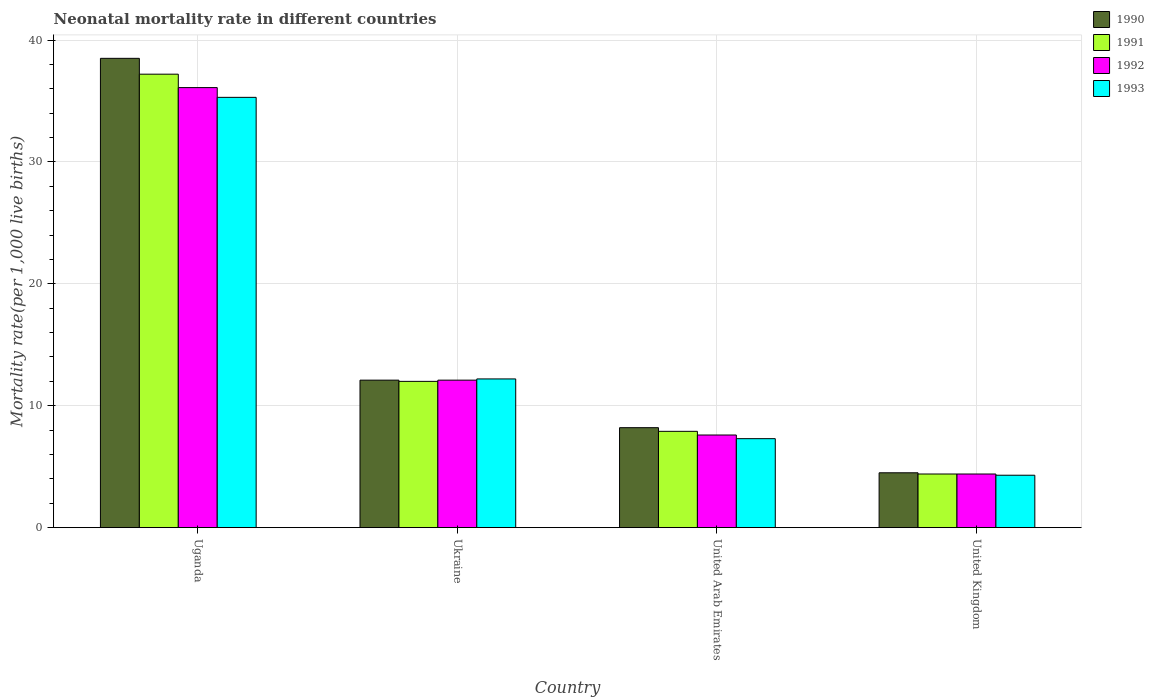How many different coloured bars are there?
Ensure brevity in your answer.  4. How many groups of bars are there?
Give a very brief answer. 4. What is the label of the 4th group of bars from the left?
Provide a succinct answer. United Kingdom. What is the neonatal mortality rate in 1990 in United Arab Emirates?
Offer a very short reply. 8.2. Across all countries, what is the maximum neonatal mortality rate in 1992?
Offer a terse response. 36.1. Across all countries, what is the minimum neonatal mortality rate in 1992?
Offer a terse response. 4.4. In which country was the neonatal mortality rate in 1990 maximum?
Offer a very short reply. Uganda. What is the total neonatal mortality rate in 1991 in the graph?
Offer a terse response. 61.5. What is the difference between the neonatal mortality rate in 1993 in United Kingdom and the neonatal mortality rate in 1991 in Uganda?
Ensure brevity in your answer.  -32.9. What is the average neonatal mortality rate in 1993 per country?
Make the answer very short. 14.77. What is the difference between the neonatal mortality rate of/in 1990 and neonatal mortality rate of/in 1992 in Uganda?
Your answer should be compact. 2.4. What is the ratio of the neonatal mortality rate in 1992 in Ukraine to that in United Arab Emirates?
Give a very brief answer. 1.59. Is the neonatal mortality rate in 1993 in Uganda less than that in United Arab Emirates?
Make the answer very short. No. Is the difference between the neonatal mortality rate in 1990 in Ukraine and United Arab Emirates greater than the difference between the neonatal mortality rate in 1992 in Ukraine and United Arab Emirates?
Provide a succinct answer. No. What is the difference between the highest and the second highest neonatal mortality rate in 1990?
Provide a short and direct response. -3.9. Is the sum of the neonatal mortality rate in 1992 in Uganda and United Arab Emirates greater than the maximum neonatal mortality rate in 1993 across all countries?
Provide a short and direct response. Yes. Is it the case that in every country, the sum of the neonatal mortality rate in 1990 and neonatal mortality rate in 1993 is greater than the sum of neonatal mortality rate in 1992 and neonatal mortality rate in 1991?
Ensure brevity in your answer.  No. How many bars are there?
Offer a very short reply. 16. Are all the bars in the graph horizontal?
Provide a succinct answer. No. How are the legend labels stacked?
Ensure brevity in your answer.  Vertical. What is the title of the graph?
Provide a succinct answer. Neonatal mortality rate in different countries. What is the label or title of the X-axis?
Your answer should be compact. Country. What is the label or title of the Y-axis?
Keep it short and to the point. Mortality rate(per 1,0 live births). What is the Mortality rate(per 1,000 live births) in 1990 in Uganda?
Your answer should be compact. 38.5. What is the Mortality rate(per 1,000 live births) in 1991 in Uganda?
Give a very brief answer. 37.2. What is the Mortality rate(per 1,000 live births) of 1992 in Uganda?
Keep it short and to the point. 36.1. What is the Mortality rate(per 1,000 live births) of 1993 in Uganda?
Your response must be concise. 35.3. What is the Mortality rate(per 1,000 live births) in 1990 in United Arab Emirates?
Keep it short and to the point. 8.2. What is the Mortality rate(per 1,000 live births) of 1993 in United Arab Emirates?
Give a very brief answer. 7.3. What is the Mortality rate(per 1,000 live births) of 1990 in United Kingdom?
Ensure brevity in your answer.  4.5. What is the Mortality rate(per 1,000 live births) in 1991 in United Kingdom?
Make the answer very short. 4.4. What is the Mortality rate(per 1,000 live births) of 1993 in United Kingdom?
Provide a short and direct response. 4.3. Across all countries, what is the maximum Mortality rate(per 1,000 live births) of 1990?
Offer a very short reply. 38.5. Across all countries, what is the maximum Mortality rate(per 1,000 live births) in 1991?
Your answer should be compact. 37.2. Across all countries, what is the maximum Mortality rate(per 1,000 live births) of 1992?
Your answer should be compact. 36.1. Across all countries, what is the maximum Mortality rate(per 1,000 live births) of 1993?
Keep it short and to the point. 35.3. Across all countries, what is the minimum Mortality rate(per 1,000 live births) in 1990?
Your answer should be very brief. 4.5. Across all countries, what is the minimum Mortality rate(per 1,000 live births) in 1992?
Keep it short and to the point. 4.4. Across all countries, what is the minimum Mortality rate(per 1,000 live births) in 1993?
Provide a short and direct response. 4.3. What is the total Mortality rate(per 1,000 live births) in 1990 in the graph?
Your answer should be very brief. 63.3. What is the total Mortality rate(per 1,000 live births) in 1991 in the graph?
Ensure brevity in your answer.  61.5. What is the total Mortality rate(per 1,000 live births) in 1992 in the graph?
Provide a succinct answer. 60.2. What is the total Mortality rate(per 1,000 live births) in 1993 in the graph?
Make the answer very short. 59.1. What is the difference between the Mortality rate(per 1,000 live births) in 1990 in Uganda and that in Ukraine?
Offer a very short reply. 26.4. What is the difference between the Mortality rate(per 1,000 live births) of 1991 in Uganda and that in Ukraine?
Your answer should be compact. 25.2. What is the difference between the Mortality rate(per 1,000 live births) in 1993 in Uganda and that in Ukraine?
Offer a very short reply. 23.1. What is the difference between the Mortality rate(per 1,000 live births) in 1990 in Uganda and that in United Arab Emirates?
Keep it short and to the point. 30.3. What is the difference between the Mortality rate(per 1,000 live births) in 1991 in Uganda and that in United Arab Emirates?
Offer a very short reply. 29.3. What is the difference between the Mortality rate(per 1,000 live births) of 1992 in Uganda and that in United Arab Emirates?
Your answer should be compact. 28.5. What is the difference between the Mortality rate(per 1,000 live births) in 1993 in Uganda and that in United Arab Emirates?
Offer a terse response. 28. What is the difference between the Mortality rate(per 1,000 live births) in 1990 in Uganda and that in United Kingdom?
Offer a very short reply. 34. What is the difference between the Mortality rate(per 1,000 live births) in 1991 in Uganda and that in United Kingdom?
Your response must be concise. 32.8. What is the difference between the Mortality rate(per 1,000 live births) in 1992 in Uganda and that in United Kingdom?
Your answer should be compact. 31.7. What is the difference between the Mortality rate(per 1,000 live births) in 1993 in Uganda and that in United Kingdom?
Keep it short and to the point. 31. What is the difference between the Mortality rate(per 1,000 live births) of 1991 in Ukraine and that in United Arab Emirates?
Offer a terse response. 4.1. What is the difference between the Mortality rate(per 1,000 live births) of 1992 in Ukraine and that in United Arab Emirates?
Give a very brief answer. 4.5. What is the difference between the Mortality rate(per 1,000 live births) of 1990 in Ukraine and that in United Kingdom?
Offer a very short reply. 7.6. What is the difference between the Mortality rate(per 1,000 live births) of 1991 in Ukraine and that in United Kingdom?
Provide a short and direct response. 7.6. What is the difference between the Mortality rate(per 1,000 live births) of 1993 in Ukraine and that in United Kingdom?
Provide a short and direct response. 7.9. What is the difference between the Mortality rate(per 1,000 live births) in 1992 in United Arab Emirates and that in United Kingdom?
Give a very brief answer. 3.2. What is the difference between the Mortality rate(per 1,000 live births) of 1990 in Uganda and the Mortality rate(per 1,000 live births) of 1992 in Ukraine?
Your response must be concise. 26.4. What is the difference between the Mortality rate(per 1,000 live births) in 1990 in Uganda and the Mortality rate(per 1,000 live births) in 1993 in Ukraine?
Ensure brevity in your answer.  26.3. What is the difference between the Mortality rate(per 1,000 live births) of 1991 in Uganda and the Mortality rate(per 1,000 live births) of 1992 in Ukraine?
Your answer should be very brief. 25.1. What is the difference between the Mortality rate(per 1,000 live births) of 1991 in Uganda and the Mortality rate(per 1,000 live births) of 1993 in Ukraine?
Ensure brevity in your answer.  25. What is the difference between the Mortality rate(per 1,000 live births) in 1992 in Uganda and the Mortality rate(per 1,000 live births) in 1993 in Ukraine?
Your response must be concise. 23.9. What is the difference between the Mortality rate(per 1,000 live births) of 1990 in Uganda and the Mortality rate(per 1,000 live births) of 1991 in United Arab Emirates?
Keep it short and to the point. 30.6. What is the difference between the Mortality rate(per 1,000 live births) of 1990 in Uganda and the Mortality rate(per 1,000 live births) of 1992 in United Arab Emirates?
Your answer should be very brief. 30.9. What is the difference between the Mortality rate(per 1,000 live births) in 1990 in Uganda and the Mortality rate(per 1,000 live births) in 1993 in United Arab Emirates?
Your response must be concise. 31.2. What is the difference between the Mortality rate(per 1,000 live births) in 1991 in Uganda and the Mortality rate(per 1,000 live births) in 1992 in United Arab Emirates?
Your response must be concise. 29.6. What is the difference between the Mortality rate(per 1,000 live births) in 1991 in Uganda and the Mortality rate(per 1,000 live births) in 1993 in United Arab Emirates?
Your answer should be very brief. 29.9. What is the difference between the Mortality rate(per 1,000 live births) of 1992 in Uganda and the Mortality rate(per 1,000 live births) of 1993 in United Arab Emirates?
Your answer should be compact. 28.8. What is the difference between the Mortality rate(per 1,000 live births) in 1990 in Uganda and the Mortality rate(per 1,000 live births) in 1991 in United Kingdom?
Offer a very short reply. 34.1. What is the difference between the Mortality rate(per 1,000 live births) in 1990 in Uganda and the Mortality rate(per 1,000 live births) in 1992 in United Kingdom?
Make the answer very short. 34.1. What is the difference between the Mortality rate(per 1,000 live births) of 1990 in Uganda and the Mortality rate(per 1,000 live births) of 1993 in United Kingdom?
Your response must be concise. 34.2. What is the difference between the Mortality rate(per 1,000 live births) in 1991 in Uganda and the Mortality rate(per 1,000 live births) in 1992 in United Kingdom?
Give a very brief answer. 32.8. What is the difference between the Mortality rate(per 1,000 live births) of 1991 in Uganda and the Mortality rate(per 1,000 live births) of 1993 in United Kingdom?
Your answer should be compact. 32.9. What is the difference between the Mortality rate(per 1,000 live births) in 1992 in Uganda and the Mortality rate(per 1,000 live births) in 1993 in United Kingdom?
Provide a succinct answer. 31.8. What is the difference between the Mortality rate(per 1,000 live births) in 1990 in Ukraine and the Mortality rate(per 1,000 live births) in 1992 in United Arab Emirates?
Your answer should be very brief. 4.5. What is the difference between the Mortality rate(per 1,000 live births) of 1990 in Ukraine and the Mortality rate(per 1,000 live births) of 1993 in United Arab Emirates?
Give a very brief answer. 4.8. What is the difference between the Mortality rate(per 1,000 live births) in 1991 in Ukraine and the Mortality rate(per 1,000 live births) in 1992 in United Arab Emirates?
Offer a terse response. 4.4. What is the difference between the Mortality rate(per 1,000 live births) in 1992 in Ukraine and the Mortality rate(per 1,000 live births) in 1993 in United Arab Emirates?
Your answer should be very brief. 4.8. What is the difference between the Mortality rate(per 1,000 live births) in 1990 in Ukraine and the Mortality rate(per 1,000 live births) in 1991 in United Kingdom?
Offer a very short reply. 7.7. What is the difference between the Mortality rate(per 1,000 live births) in 1990 in Ukraine and the Mortality rate(per 1,000 live births) in 1993 in United Kingdom?
Your answer should be compact. 7.8. What is the difference between the Mortality rate(per 1,000 live births) of 1991 in Ukraine and the Mortality rate(per 1,000 live births) of 1992 in United Kingdom?
Offer a very short reply. 7.6. What is the difference between the Mortality rate(per 1,000 live births) in 1992 in Ukraine and the Mortality rate(per 1,000 live births) in 1993 in United Kingdom?
Your answer should be very brief. 7.8. What is the average Mortality rate(per 1,000 live births) in 1990 per country?
Give a very brief answer. 15.82. What is the average Mortality rate(per 1,000 live births) of 1991 per country?
Give a very brief answer. 15.38. What is the average Mortality rate(per 1,000 live births) in 1992 per country?
Your response must be concise. 15.05. What is the average Mortality rate(per 1,000 live births) in 1993 per country?
Ensure brevity in your answer.  14.78. What is the difference between the Mortality rate(per 1,000 live births) of 1990 and Mortality rate(per 1,000 live births) of 1993 in Uganda?
Provide a succinct answer. 3.2. What is the difference between the Mortality rate(per 1,000 live births) in 1991 and Mortality rate(per 1,000 live births) in 1993 in Uganda?
Give a very brief answer. 1.9. What is the difference between the Mortality rate(per 1,000 live births) of 1992 and Mortality rate(per 1,000 live births) of 1993 in Uganda?
Offer a terse response. 0.8. What is the difference between the Mortality rate(per 1,000 live births) in 1990 and Mortality rate(per 1,000 live births) in 1993 in Ukraine?
Your response must be concise. -0.1. What is the difference between the Mortality rate(per 1,000 live births) of 1991 and Mortality rate(per 1,000 live births) of 1992 in Ukraine?
Provide a short and direct response. -0.1. What is the difference between the Mortality rate(per 1,000 live births) of 1991 and Mortality rate(per 1,000 live births) of 1993 in Ukraine?
Make the answer very short. -0.2. What is the difference between the Mortality rate(per 1,000 live births) in 1992 and Mortality rate(per 1,000 live births) in 1993 in Ukraine?
Keep it short and to the point. -0.1. What is the difference between the Mortality rate(per 1,000 live births) in 1990 and Mortality rate(per 1,000 live births) in 1991 in United Arab Emirates?
Make the answer very short. 0.3. What is the difference between the Mortality rate(per 1,000 live births) in 1990 and Mortality rate(per 1,000 live births) in 1992 in United Arab Emirates?
Offer a very short reply. 0.6. What is the difference between the Mortality rate(per 1,000 live births) in 1992 and Mortality rate(per 1,000 live births) in 1993 in United Arab Emirates?
Offer a very short reply. 0.3. What is the difference between the Mortality rate(per 1,000 live births) in 1990 and Mortality rate(per 1,000 live births) in 1991 in United Kingdom?
Offer a terse response. 0.1. What is the difference between the Mortality rate(per 1,000 live births) of 1990 and Mortality rate(per 1,000 live births) of 1992 in United Kingdom?
Give a very brief answer. 0.1. What is the difference between the Mortality rate(per 1,000 live births) of 1991 and Mortality rate(per 1,000 live births) of 1993 in United Kingdom?
Make the answer very short. 0.1. What is the ratio of the Mortality rate(per 1,000 live births) in 1990 in Uganda to that in Ukraine?
Provide a short and direct response. 3.18. What is the ratio of the Mortality rate(per 1,000 live births) in 1992 in Uganda to that in Ukraine?
Offer a very short reply. 2.98. What is the ratio of the Mortality rate(per 1,000 live births) in 1993 in Uganda to that in Ukraine?
Ensure brevity in your answer.  2.89. What is the ratio of the Mortality rate(per 1,000 live births) of 1990 in Uganda to that in United Arab Emirates?
Your answer should be compact. 4.7. What is the ratio of the Mortality rate(per 1,000 live births) of 1991 in Uganda to that in United Arab Emirates?
Ensure brevity in your answer.  4.71. What is the ratio of the Mortality rate(per 1,000 live births) of 1992 in Uganda to that in United Arab Emirates?
Offer a very short reply. 4.75. What is the ratio of the Mortality rate(per 1,000 live births) in 1993 in Uganda to that in United Arab Emirates?
Give a very brief answer. 4.84. What is the ratio of the Mortality rate(per 1,000 live births) of 1990 in Uganda to that in United Kingdom?
Your response must be concise. 8.56. What is the ratio of the Mortality rate(per 1,000 live births) of 1991 in Uganda to that in United Kingdom?
Offer a very short reply. 8.45. What is the ratio of the Mortality rate(per 1,000 live births) in 1992 in Uganda to that in United Kingdom?
Provide a short and direct response. 8.2. What is the ratio of the Mortality rate(per 1,000 live births) of 1993 in Uganda to that in United Kingdom?
Keep it short and to the point. 8.21. What is the ratio of the Mortality rate(per 1,000 live births) in 1990 in Ukraine to that in United Arab Emirates?
Your answer should be very brief. 1.48. What is the ratio of the Mortality rate(per 1,000 live births) of 1991 in Ukraine to that in United Arab Emirates?
Keep it short and to the point. 1.52. What is the ratio of the Mortality rate(per 1,000 live births) in 1992 in Ukraine to that in United Arab Emirates?
Keep it short and to the point. 1.59. What is the ratio of the Mortality rate(per 1,000 live births) in 1993 in Ukraine to that in United Arab Emirates?
Your answer should be compact. 1.67. What is the ratio of the Mortality rate(per 1,000 live births) of 1990 in Ukraine to that in United Kingdom?
Provide a succinct answer. 2.69. What is the ratio of the Mortality rate(per 1,000 live births) in 1991 in Ukraine to that in United Kingdom?
Your answer should be very brief. 2.73. What is the ratio of the Mortality rate(per 1,000 live births) of 1992 in Ukraine to that in United Kingdom?
Your response must be concise. 2.75. What is the ratio of the Mortality rate(per 1,000 live births) in 1993 in Ukraine to that in United Kingdom?
Your answer should be very brief. 2.84. What is the ratio of the Mortality rate(per 1,000 live births) in 1990 in United Arab Emirates to that in United Kingdom?
Your response must be concise. 1.82. What is the ratio of the Mortality rate(per 1,000 live births) of 1991 in United Arab Emirates to that in United Kingdom?
Offer a very short reply. 1.8. What is the ratio of the Mortality rate(per 1,000 live births) in 1992 in United Arab Emirates to that in United Kingdom?
Offer a very short reply. 1.73. What is the ratio of the Mortality rate(per 1,000 live births) of 1993 in United Arab Emirates to that in United Kingdom?
Ensure brevity in your answer.  1.7. What is the difference between the highest and the second highest Mortality rate(per 1,000 live births) of 1990?
Provide a short and direct response. 26.4. What is the difference between the highest and the second highest Mortality rate(per 1,000 live births) in 1991?
Keep it short and to the point. 25.2. What is the difference between the highest and the second highest Mortality rate(per 1,000 live births) in 1993?
Give a very brief answer. 23.1. What is the difference between the highest and the lowest Mortality rate(per 1,000 live births) of 1990?
Your answer should be very brief. 34. What is the difference between the highest and the lowest Mortality rate(per 1,000 live births) of 1991?
Offer a very short reply. 32.8. What is the difference between the highest and the lowest Mortality rate(per 1,000 live births) of 1992?
Provide a succinct answer. 31.7. 